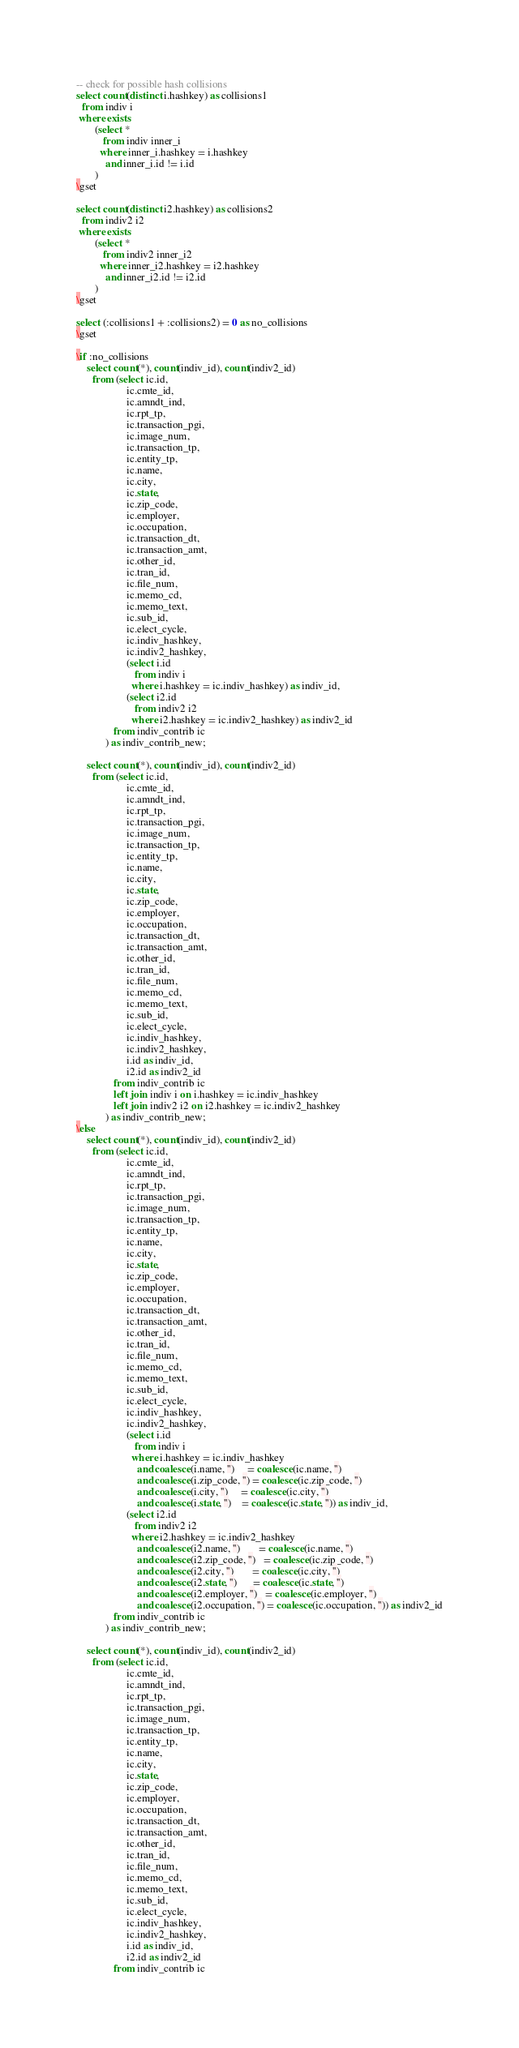Convert code to text. <code><loc_0><loc_0><loc_500><loc_500><_SQL_>-- check for possible hash collisions
select count(distinct i.hashkey) as collisions1
  from indiv i
 where exists
       (select *
          from indiv inner_i
         where inner_i.hashkey = i.hashkey
           and inner_i.id != i.id
       )
\gset

select count(distinct i2.hashkey) as collisions2
  from indiv2 i2
 where exists
       (select *
          from indiv2 inner_i2
         where inner_i2.hashkey = i2.hashkey
           and inner_i2.id != i2.id
       )
\gset

select (:collisions1 + :collisions2) = 0 as no_collisions
\gset

\if :no_collisions
    select count(*), count(indiv_id), count(indiv2_id)
      from (select ic.id,
                   ic.cmte_id,
                   ic.amndt_ind,
                   ic.rpt_tp,
                   ic.transaction_pgi,
                   ic.image_num,
                   ic.transaction_tp,
                   ic.entity_tp,
                   ic.name,
                   ic.city,
                   ic.state,
                   ic.zip_code,
                   ic.employer,
                   ic.occupation,
                   ic.transaction_dt,
                   ic.transaction_amt,
                   ic.other_id,
                   ic.tran_id,
                   ic.file_num,
                   ic.memo_cd,
                   ic.memo_text,
                   ic.sub_id,
                   ic.elect_cycle,
                   ic.indiv_hashkey,
                   ic.indiv2_hashkey,
                   (select i.id
                      from indiv i
                     where i.hashkey = ic.indiv_hashkey) as indiv_id,
                   (select i2.id
                      from indiv2 i2
                     where i2.hashkey = ic.indiv2_hashkey) as indiv2_id
              from indiv_contrib ic
           ) as indiv_contrib_new;

    select count(*), count(indiv_id), count(indiv2_id)
      from (select ic.id,
                   ic.cmte_id,
                   ic.amndt_ind,
                   ic.rpt_tp,
                   ic.transaction_pgi,
                   ic.image_num,
                   ic.transaction_tp,
                   ic.entity_tp,
                   ic.name,
                   ic.city,
                   ic.state,
                   ic.zip_code,
                   ic.employer,
                   ic.occupation,
                   ic.transaction_dt,
                   ic.transaction_amt,
                   ic.other_id,
                   ic.tran_id,
                   ic.file_num,
                   ic.memo_cd,
                   ic.memo_text,
                   ic.sub_id,
                   ic.elect_cycle,
                   ic.indiv_hashkey,
                   ic.indiv2_hashkey,
                   i.id as indiv_id,
                   i2.id as indiv2_id
              from indiv_contrib ic
              left join indiv i on i.hashkey = ic.indiv_hashkey
              left join indiv2 i2 on i2.hashkey = ic.indiv2_hashkey
           ) as indiv_contrib_new;
\else
    select count(*), count(indiv_id), count(indiv2_id)
      from (select ic.id,
                   ic.cmte_id,
                   ic.amndt_ind,
                   ic.rpt_tp,
                   ic.transaction_pgi,
                   ic.image_num,
                   ic.transaction_tp,
                   ic.entity_tp,
                   ic.name,
                   ic.city,
                   ic.state,
                   ic.zip_code,
                   ic.employer,
                   ic.occupation,
                   ic.transaction_dt,
                   ic.transaction_amt,
                   ic.other_id,
                   ic.tran_id,
                   ic.file_num,
                   ic.memo_cd,
                   ic.memo_text,
                   ic.sub_id,
                   ic.elect_cycle,
                   ic.indiv_hashkey,
                   ic.indiv2_hashkey,
                   (select i.id
                      from indiv i
                     where i.hashkey = ic.indiv_hashkey
                       and coalesce(i.name, '')     = coalesce(ic.name, '')
                       and coalesce(i.zip_code, '') = coalesce(ic.zip_code, '')
                       and coalesce(i.city, '')     = coalesce(ic.city, '')
                       and coalesce(i.state, '')    = coalesce(ic.state, '')) as indiv_id,
                   (select i2.id
                      from indiv2 i2
                     where i2.hashkey = ic.indiv2_hashkey
                       and coalesce(i2.name, '')       = coalesce(ic.name, '')
                       and coalesce(i2.zip_code, '')   = coalesce(ic.zip_code, '')
                       and coalesce(i2.city, '')       = coalesce(ic.city, '')
                       and coalesce(i2.state, '')      = coalesce(ic.state, '')
                       and coalesce(i2.employer, '')   = coalesce(ic.employer, '')
                       and coalesce(i2.occupation, '') = coalesce(ic.occupation, '')) as indiv2_id
              from indiv_contrib ic
           ) as indiv_contrib_new;

    select count(*), count(indiv_id), count(indiv2_id)
      from (select ic.id,
                   ic.cmte_id,
                   ic.amndt_ind,
                   ic.rpt_tp,
                   ic.transaction_pgi,
                   ic.image_num,
                   ic.transaction_tp,
                   ic.entity_tp,
                   ic.name,
                   ic.city,
                   ic.state,
                   ic.zip_code,
                   ic.employer,
                   ic.occupation,
                   ic.transaction_dt,
                   ic.transaction_amt,
                   ic.other_id,
                   ic.tran_id,
                   ic.file_num,
                   ic.memo_cd,
                   ic.memo_text,
                   ic.sub_id,
                   ic.elect_cycle,
                   ic.indiv_hashkey,
                   ic.indiv2_hashkey,
                   i.id as indiv_id,
                   i2.id as indiv2_id
              from indiv_contrib ic</code> 